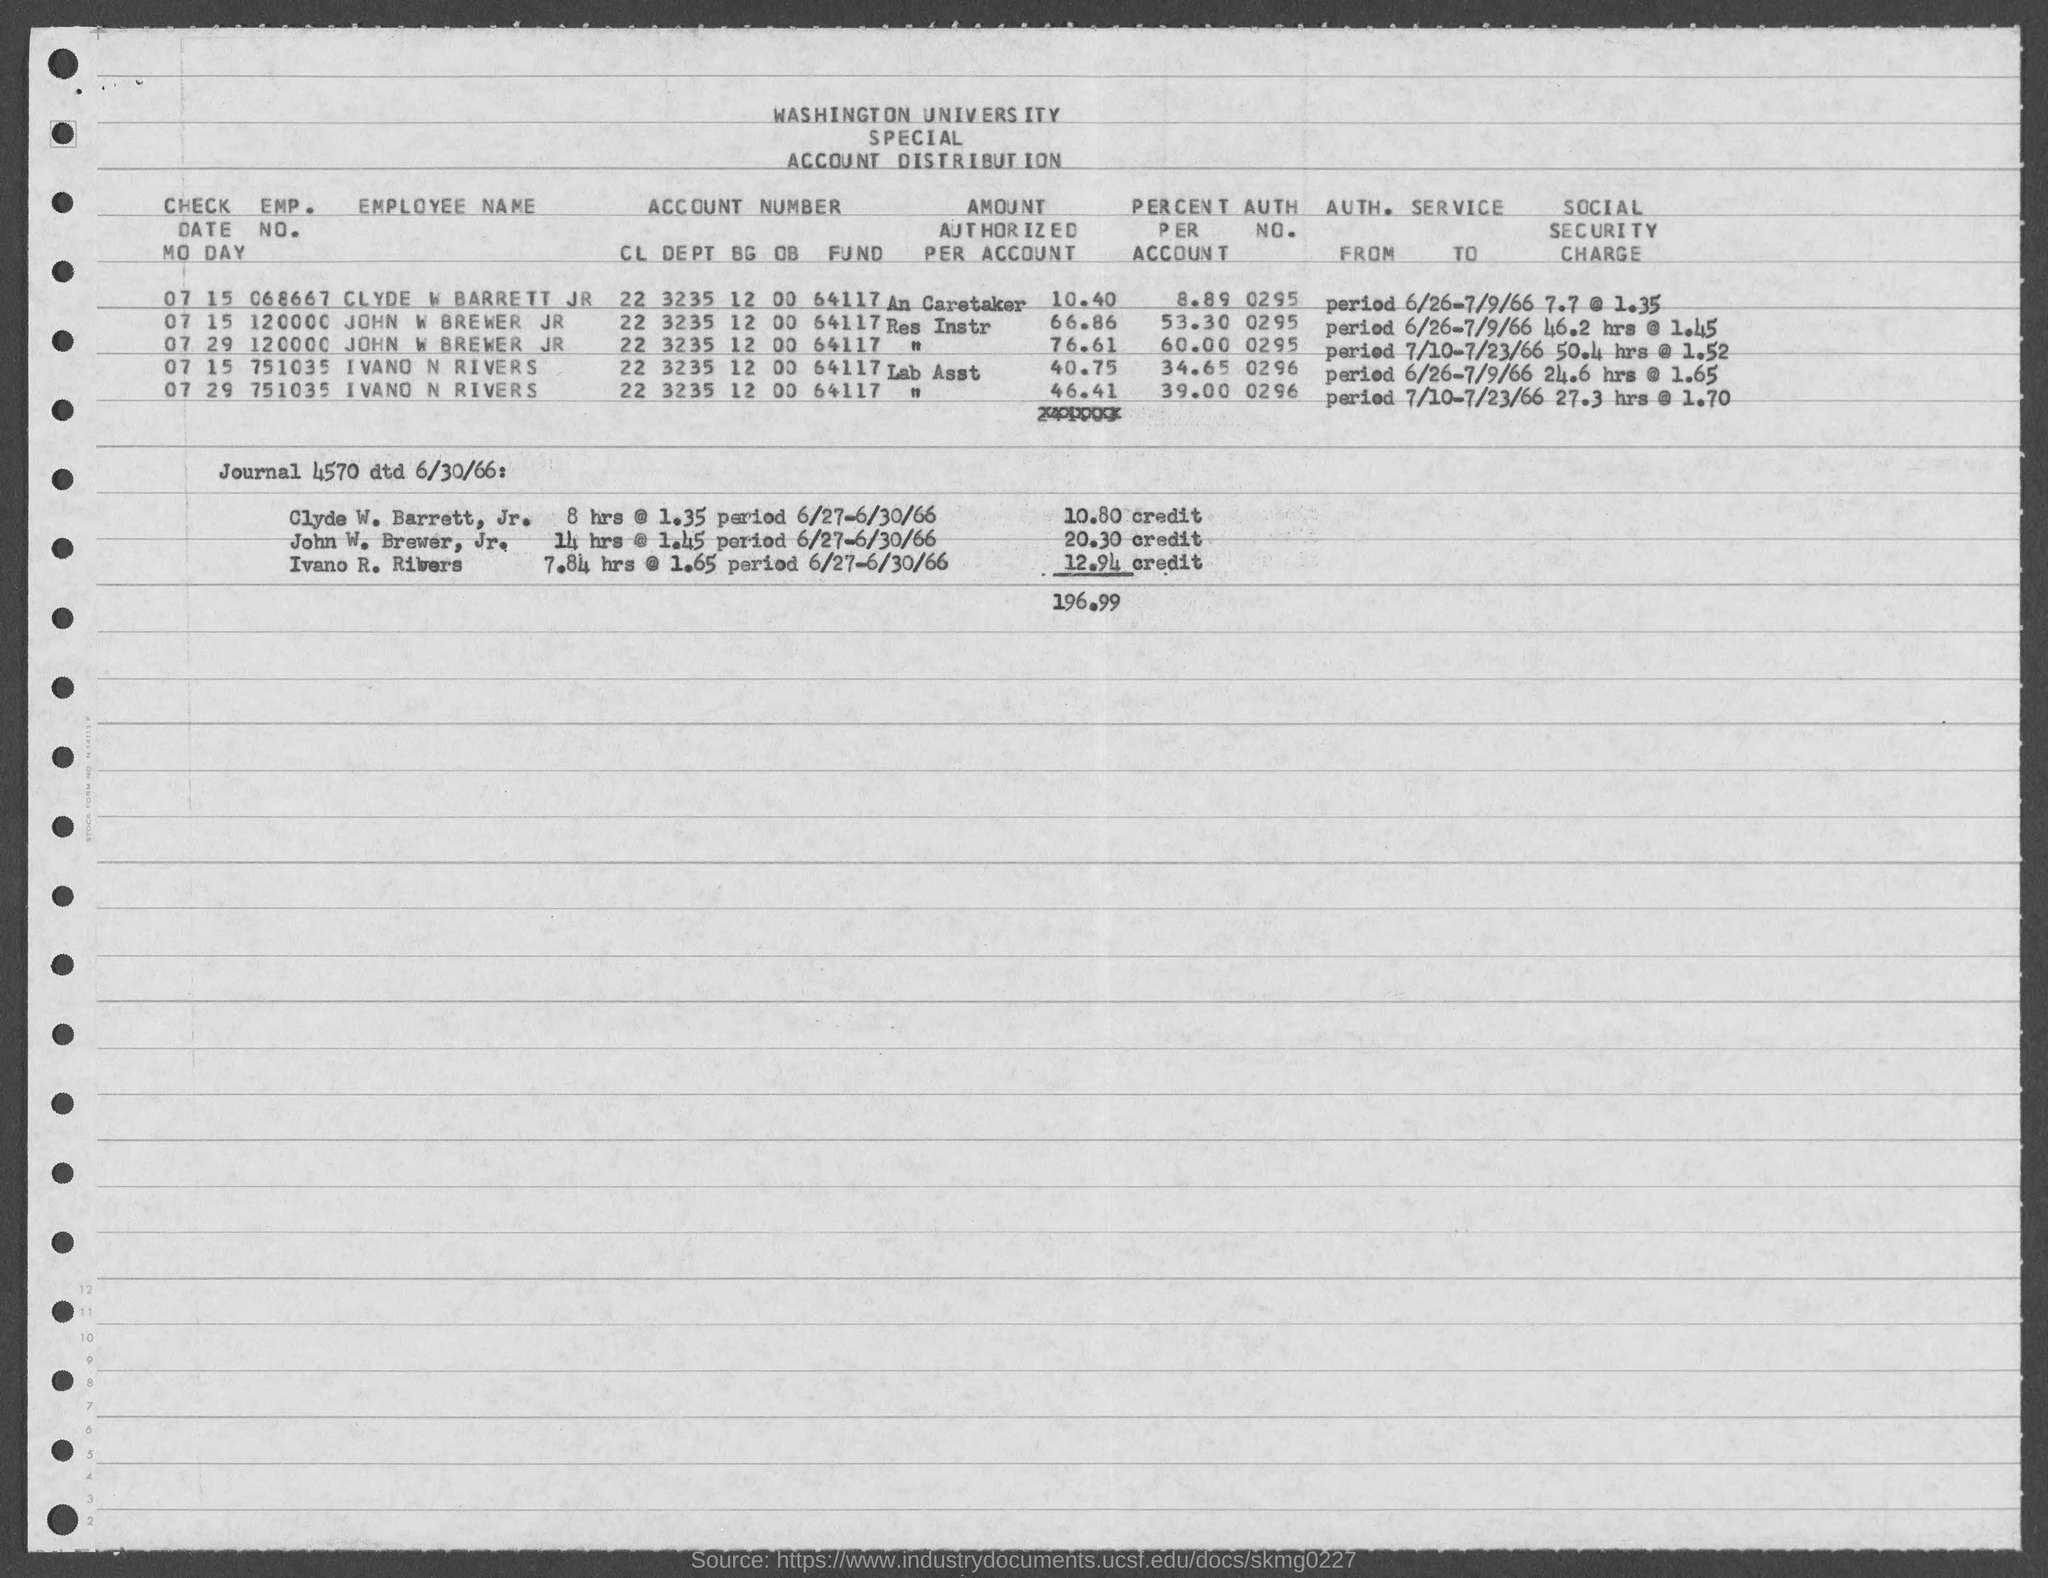What is the emp. no. of clyde w barrett jr ?
Offer a very short reply. 068667. What is the emp. no. of john w brewer jr as mentioned in the given page ?
Ensure brevity in your answer.  120000. What is the emp. no. of ivano n rivers as mentioned in the given page ?
Offer a terse response. 751035. What is the auth no. for clyde w barrett jr ?
Your answer should be very brief. 0295. What is the auth no. for john w brewer jr ?
Your answer should be very brief. 0295. What is the auth no.for ivano n rivers ?
Ensure brevity in your answer.  0296. 